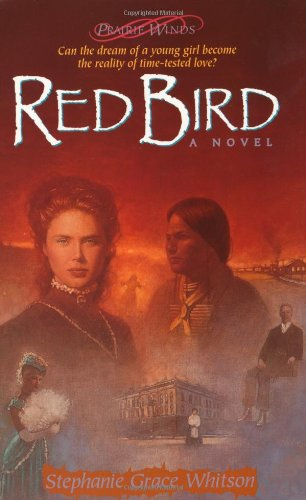Who wrote this book? The book 'Red Bird' was authored by Stephanie Grace Whitson, who is known for her detailed historical novels often set in frontier America. 